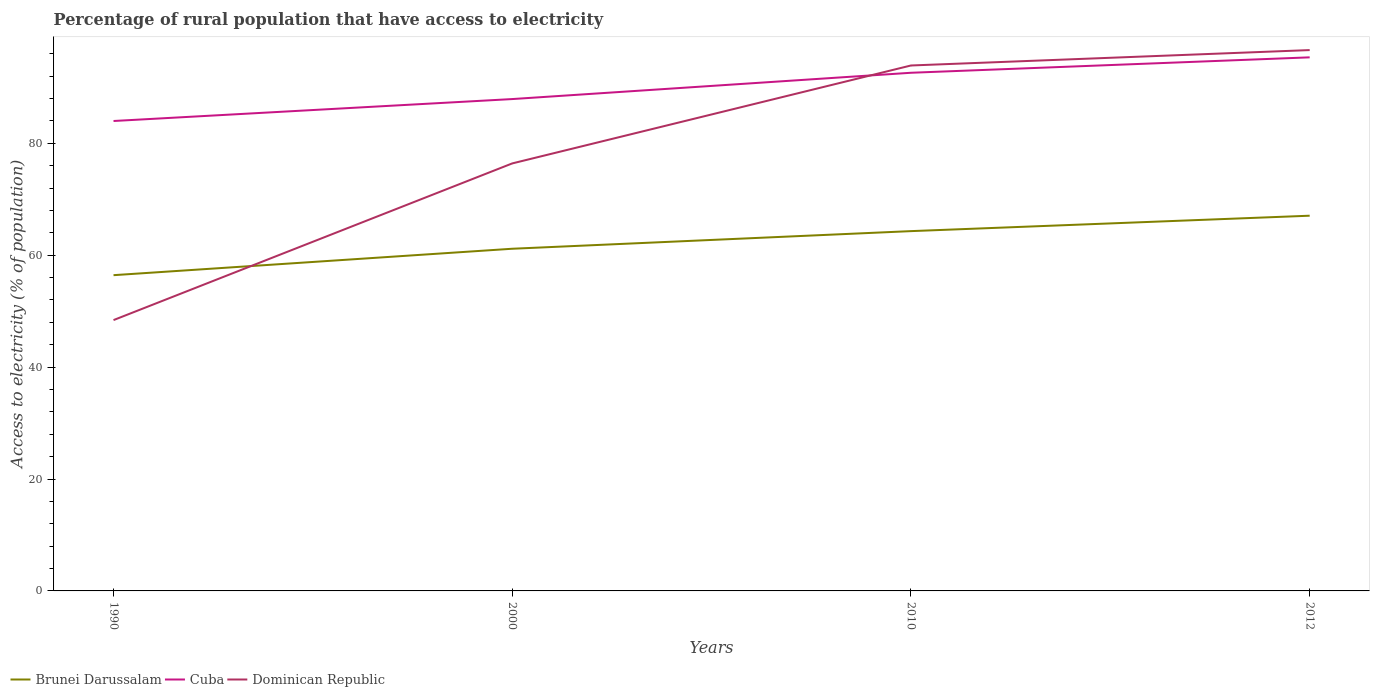Does the line corresponding to Dominican Republic intersect with the line corresponding to Cuba?
Your response must be concise. Yes. Across all years, what is the maximum percentage of rural population that have access to electricity in Cuba?
Your answer should be compact. 83.98. In which year was the percentage of rural population that have access to electricity in Dominican Republic maximum?
Give a very brief answer. 1990. What is the total percentage of rural population that have access to electricity in Cuba in the graph?
Your response must be concise. -4.7. What is the difference between the highest and the second highest percentage of rural population that have access to electricity in Cuba?
Keep it short and to the point. 11.38. What is the difference between the highest and the lowest percentage of rural population that have access to electricity in Brunei Darussalam?
Your answer should be compact. 2. How many years are there in the graph?
Your answer should be very brief. 4. What is the difference between two consecutive major ticks on the Y-axis?
Your response must be concise. 20. What is the title of the graph?
Give a very brief answer. Percentage of rural population that have access to electricity. Does "High income" appear as one of the legend labels in the graph?
Offer a terse response. No. What is the label or title of the Y-axis?
Provide a short and direct response. Access to electricity (% of population). What is the Access to electricity (% of population) in Brunei Darussalam in 1990?
Keep it short and to the point. 56.43. What is the Access to electricity (% of population) in Cuba in 1990?
Provide a succinct answer. 83.98. What is the Access to electricity (% of population) of Dominican Republic in 1990?
Offer a very short reply. 48.4. What is the Access to electricity (% of population) of Brunei Darussalam in 2000?
Make the answer very short. 61.15. What is the Access to electricity (% of population) in Cuba in 2000?
Offer a very short reply. 87.9. What is the Access to electricity (% of population) in Dominican Republic in 2000?
Keep it short and to the point. 76.4. What is the Access to electricity (% of population) of Brunei Darussalam in 2010?
Provide a short and direct response. 64.3. What is the Access to electricity (% of population) of Cuba in 2010?
Your answer should be compact. 92.6. What is the Access to electricity (% of population) in Dominican Republic in 2010?
Provide a short and direct response. 93.9. What is the Access to electricity (% of population) of Brunei Darussalam in 2012?
Provide a succinct answer. 67.05. What is the Access to electricity (% of population) of Cuba in 2012?
Keep it short and to the point. 95.35. What is the Access to electricity (% of population) of Dominican Republic in 2012?
Provide a short and direct response. 96.65. Across all years, what is the maximum Access to electricity (% of population) in Brunei Darussalam?
Offer a very short reply. 67.05. Across all years, what is the maximum Access to electricity (% of population) in Cuba?
Your answer should be compact. 95.35. Across all years, what is the maximum Access to electricity (% of population) of Dominican Republic?
Offer a very short reply. 96.65. Across all years, what is the minimum Access to electricity (% of population) of Brunei Darussalam?
Keep it short and to the point. 56.43. Across all years, what is the minimum Access to electricity (% of population) of Cuba?
Provide a succinct answer. 83.98. Across all years, what is the minimum Access to electricity (% of population) in Dominican Republic?
Provide a short and direct response. 48.4. What is the total Access to electricity (% of population) in Brunei Darussalam in the graph?
Your response must be concise. 248.93. What is the total Access to electricity (% of population) of Cuba in the graph?
Ensure brevity in your answer.  359.83. What is the total Access to electricity (% of population) in Dominican Republic in the graph?
Make the answer very short. 315.35. What is the difference between the Access to electricity (% of population) of Brunei Darussalam in 1990 and that in 2000?
Provide a succinct answer. -4.72. What is the difference between the Access to electricity (% of population) of Cuba in 1990 and that in 2000?
Make the answer very short. -3.92. What is the difference between the Access to electricity (% of population) of Dominican Republic in 1990 and that in 2000?
Ensure brevity in your answer.  -28. What is the difference between the Access to electricity (% of population) of Brunei Darussalam in 1990 and that in 2010?
Your answer should be compact. -7.87. What is the difference between the Access to electricity (% of population) of Cuba in 1990 and that in 2010?
Offer a terse response. -8.62. What is the difference between the Access to electricity (% of population) in Dominican Republic in 1990 and that in 2010?
Provide a succinct answer. -45.5. What is the difference between the Access to electricity (% of population) of Brunei Darussalam in 1990 and that in 2012?
Offer a terse response. -10.63. What is the difference between the Access to electricity (% of population) of Cuba in 1990 and that in 2012?
Provide a short and direct response. -11.38. What is the difference between the Access to electricity (% of population) of Dominican Republic in 1990 and that in 2012?
Provide a succinct answer. -48.25. What is the difference between the Access to electricity (% of population) in Brunei Darussalam in 2000 and that in 2010?
Your response must be concise. -3.15. What is the difference between the Access to electricity (% of population) in Dominican Republic in 2000 and that in 2010?
Provide a short and direct response. -17.5. What is the difference between the Access to electricity (% of population) in Brunei Darussalam in 2000 and that in 2012?
Give a very brief answer. -5.9. What is the difference between the Access to electricity (% of population) of Cuba in 2000 and that in 2012?
Offer a very short reply. -7.45. What is the difference between the Access to electricity (% of population) of Dominican Republic in 2000 and that in 2012?
Provide a succinct answer. -20.25. What is the difference between the Access to electricity (% of population) in Brunei Darussalam in 2010 and that in 2012?
Keep it short and to the point. -2.75. What is the difference between the Access to electricity (% of population) in Cuba in 2010 and that in 2012?
Your answer should be very brief. -2.75. What is the difference between the Access to electricity (% of population) of Dominican Republic in 2010 and that in 2012?
Ensure brevity in your answer.  -2.75. What is the difference between the Access to electricity (% of population) in Brunei Darussalam in 1990 and the Access to electricity (% of population) in Cuba in 2000?
Offer a terse response. -31.47. What is the difference between the Access to electricity (% of population) in Brunei Darussalam in 1990 and the Access to electricity (% of population) in Dominican Republic in 2000?
Your answer should be very brief. -19.97. What is the difference between the Access to electricity (% of population) of Cuba in 1990 and the Access to electricity (% of population) of Dominican Republic in 2000?
Make the answer very short. 7.58. What is the difference between the Access to electricity (% of population) of Brunei Darussalam in 1990 and the Access to electricity (% of population) of Cuba in 2010?
Offer a terse response. -36.17. What is the difference between the Access to electricity (% of population) in Brunei Darussalam in 1990 and the Access to electricity (% of population) in Dominican Republic in 2010?
Your answer should be compact. -37.47. What is the difference between the Access to electricity (% of population) in Cuba in 1990 and the Access to electricity (% of population) in Dominican Republic in 2010?
Your answer should be very brief. -9.92. What is the difference between the Access to electricity (% of population) of Brunei Darussalam in 1990 and the Access to electricity (% of population) of Cuba in 2012?
Offer a terse response. -38.93. What is the difference between the Access to electricity (% of population) in Brunei Darussalam in 1990 and the Access to electricity (% of population) in Dominican Republic in 2012?
Your answer should be compact. -40.23. What is the difference between the Access to electricity (% of population) in Cuba in 1990 and the Access to electricity (% of population) in Dominican Republic in 2012?
Offer a very short reply. -12.68. What is the difference between the Access to electricity (% of population) of Brunei Darussalam in 2000 and the Access to electricity (% of population) of Cuba in 2010?
Your answer should be very brief. -31.45. What is the difference between the Access to electricity (% of population) in Brunei Darussalam in 2000 and the Access to electricity (% of population) in Dominican Republic in 2010?
Keep it short and to the point. -32.75. What is the difference between the Access to electricity (% of population) in Brunei Darussalam in 2000 and the Access to electricity (% of population) in Cuba in 2012?
Keep it short and to the point. -34.2. What is the difference between the Access to electricity (% of population) of Brunei Darussalam in 2000 and the Access to electricity (% of population) of Dominican Republic in 2012?
Provide a succinct answer. -35.5. What is the difference between the Access to electricity (% of population) of Cuba in 2000 and the Access to electricity (% of population) of Dominican Republic in 2012?
Your answer should be compact. -8.75. What is the difference between the Access to electricity (% of population) of Brunei Darussalam in 2010 and the Access to electricity (% of population) of Cuba in 2012?
Provide a short and direct response. -31.05. What is the difference between the Access to electricity (% of population) in Brunei Darussalam in 2010 and the Access to electricity (% of population) in Dominican Republic in 2012?
Your response must be concise. -32.35. What is the difference between the Access to electricity (% of population) of Cuba in 2010 and the Access to electricity (% of population) of Dominican Republic in 2012?
Provide a succinct answer. -4.05. What is the average Access to electricity (% of population) of Brunei Darussalam per year?
Offer a very short reply. 62.23. What is the average Access to electricity (% of population) of Cuba per year?
Give a very brief answer. 89.96. What is the average Access to electricity (% of population) in Dominican Republic per year?
Your answer should be very brief. 78.84. In the year 1990, what is the difference between the Access to electricity (% of population) in Brunei Darussalam and Access to electricity (% of population) in Cuba?
Provide a succinct answer. -27.55. In the year 1990, what is the difference between the Access to electricity (% of population) of Brunei Darussalam and Access to electricity (% of population) of Dominican Republic?
Your answer should be compact. 8.03. In the year 1990, what is the difference between the Access to electricity (% of population) in Cuba and Access to electricity (% of population) in Dominican Republic?
Make the answer very short. 35.58. In the year 2000, what is the difference between the Access to electricity (% of population) of Brunei Darussalam and Access to electricity (% of population) of Cuba?
Offer a terse response. -26.75. In the year 2000, what is the difference between the Access to electricity (% of population) of Brunei Darussalam and Access to electricity (% of population) of Dominican Republic?
Offer a very short reply. -15.25. In the year 2010, what is the difference between the Access to electricity (% of population) of Brunei Darussalam and Access to electricity (% of population) of Cuba?
Your answer should be very brief. -28.3. In the year 2010, what is the difference between the Access to electricity (% of population) in Brunei Darussalam and Access to electricity (% of population) in Dominican Republic?
Your response must be concise. -29.6. In the year 2012, what is the difference between the Access to electricity (% of population) in Brunei Darussalam and Access to electricity (% of population) in Cuba?
Your answer should be compact. -28.3. In the year 2012, what is the difference between the Access to electricity (% of population) in Brunei Darussalam and Access to electricity (% of population) in Dominican Republic?
Provide a succinct answer. -29.6. What is the ratio of the Access to electricity (% of population) in Brunei Darussalam in 1990 to that in 2000?
Offer a very short reply. 0.92. What is the ratio of the Access to electricity (% of population) in Cuba in 1990 to that in 2000?
Offer a very short reply. 0.96. What is the ratio of the Access to electricity (% of population) in Dominican Republic in 1990 to that in 2000?
Ensure brevity in your answer.  0.63. What is the ratio of the Access to electricity (% of population) of Brunei Darussalam in 1990 to that in 2010?
Keep it short and to the point. 0.88. What is the ratio of the Access to electricity (% of population) in Cuba in 1990 to that in 2010?
Offer a terse response. 0.91. What is the ratio of the Access to electricity (% of population) of Dominican Republic in 1990 to that in 2010?
Make the answer very short. 0.52. What is the ratio of the Access to electricity (% of population) of Brunei Darussalam in 1990 to that in 2012?
Ensure brevity in your answer.  0.84. What is the ratio of the Access to electricity (% of population) of Cuba in 1990 to that in 2012?
Offer a terse response. 0.88. What is the ratio of the Access to electricity (% of population) of Dominican Republic in 1990 to that in 2012?
Your answer should be compact. 0.5. What is the ratio of the Access to electricity (% of population) of Brunei Darussalam in 2000 to that in 2010?
Make the answer very short. 0.95. What is the ratio of the Access to electricity (% of population) of Cuba in 2000 to that in 2010?
Your answer should be compact. 0.95. What is the ratio of the Access to electricity (% of population) of Dominican Republic in 2000 to that in 2010?
Your answer should be compact. 0.81. What is the ratio of the Access to electricity (% of population) of Brunei Darussalam in 2000 to that in 2012?
Provide a short and direct response. 0.91. What is the ratio of the Access to electricity (% of population) of Cuba in 2000 to that in 2012?
Your answer should be compact. 0.92. What is the ratio of the Access to electricity (% of population) in Dominican Republic in 2000 to that in 2012?
Provide a succinct answer. 0.79. What is the ratio of the Access to electricity (% of population) of Brunei Darussalam in 2010 to that in 2012?
Offer a terse response. 0.96. What is the ratio of the Access to electricity (% of population) in Cuba in 2010 to that in 2012?
Provide a succinct answer. 0.97. What is the ratio of the Access to electricity (% of population) of Dominican Republic in 2010 to that in 2012?
Make the answer very short. 0.97. What is the difference between the highest and the second highest Access to electricity (% of population) in Brunei Darussalam?
Offer a very short reply. 2.75. What is the difference between the highest and the second highest Access to electricity (% of population) of Cuba?
Provide a short and direct response. 2.75. What is the difference between the highest and the second highest Access to electricity (% of population) in Dominican Republic?
Provide a short and direct response. 2.75. What is the difference between the highest and the lowest Access to electricity (% of population) in Brunei Darussalam?
Provide a short and direct response. 10.63. What is the difference between the highest and the lowest Access to electricity (% of population) in Cuba?
Offer a very short reply. 11.38. What is the difference between the highest and the lowest Access to electricity (% of population) of Dominican Republic?
Provide a succinct answer. 48.25. 